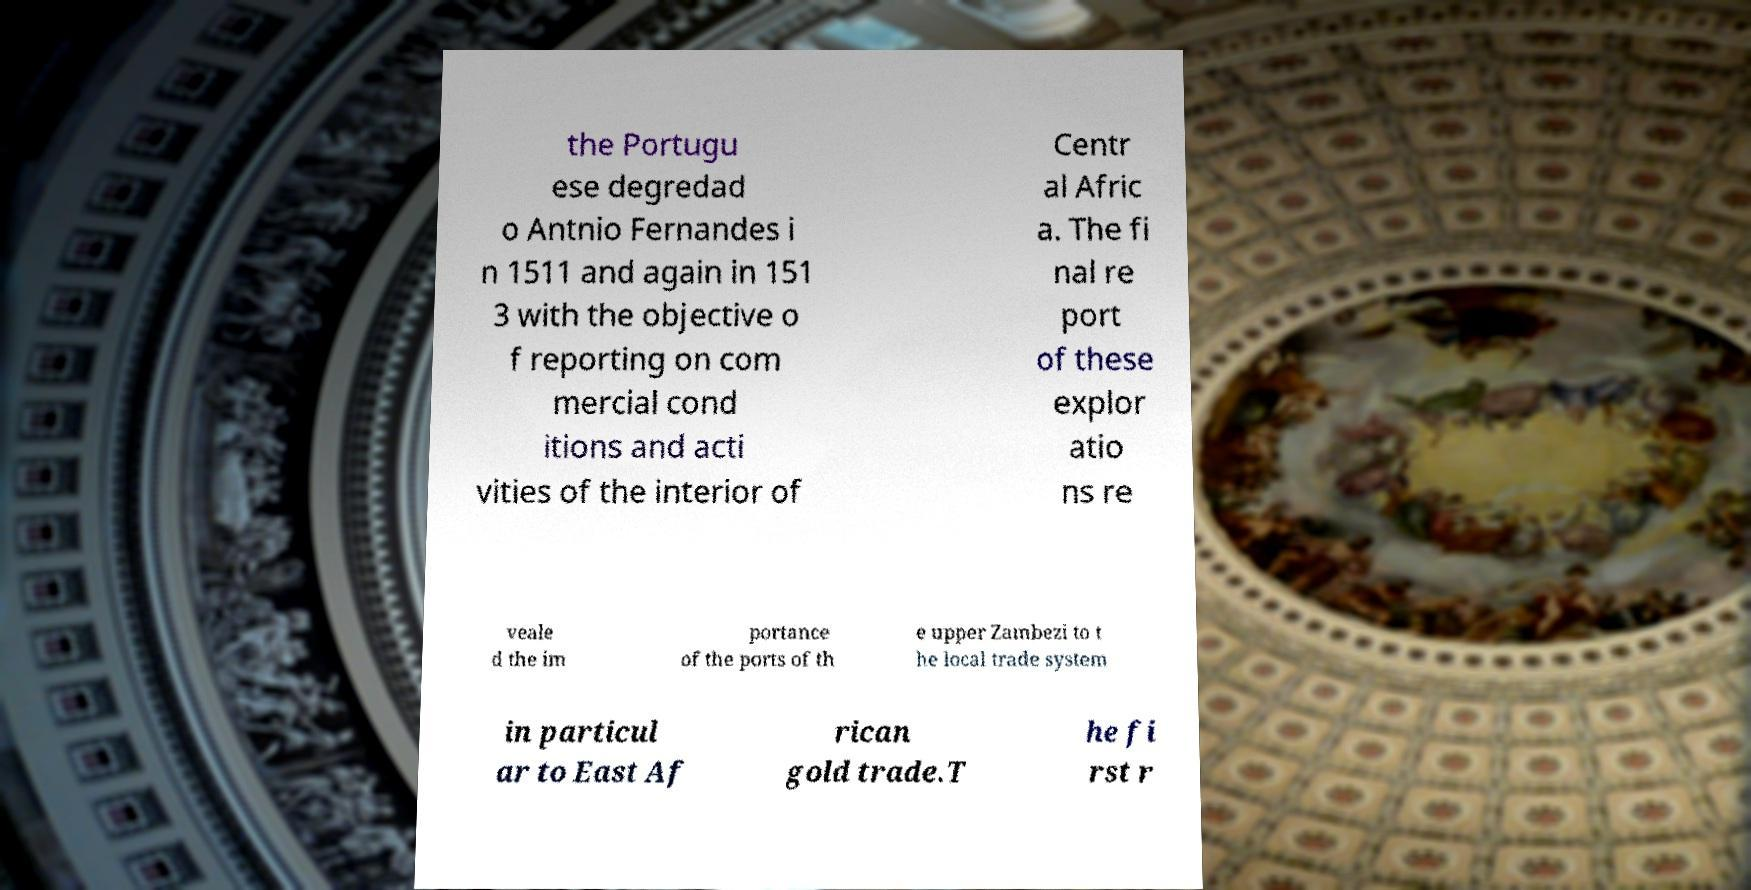Could you extract and type out the text from this image? the Portugu ese degredad o Antnio Fernandes i n 1511 and again in 151 3 with the objective o f reporting on com mercial cond itions and acti vities of the interior of Centr al Afric a. The fi nal re port of these explor atio ns re veale d the im portance of the ports of th e upper Zambezi to t he local trade system in particul ar to East Af rican gold trade.T he fi rst r 